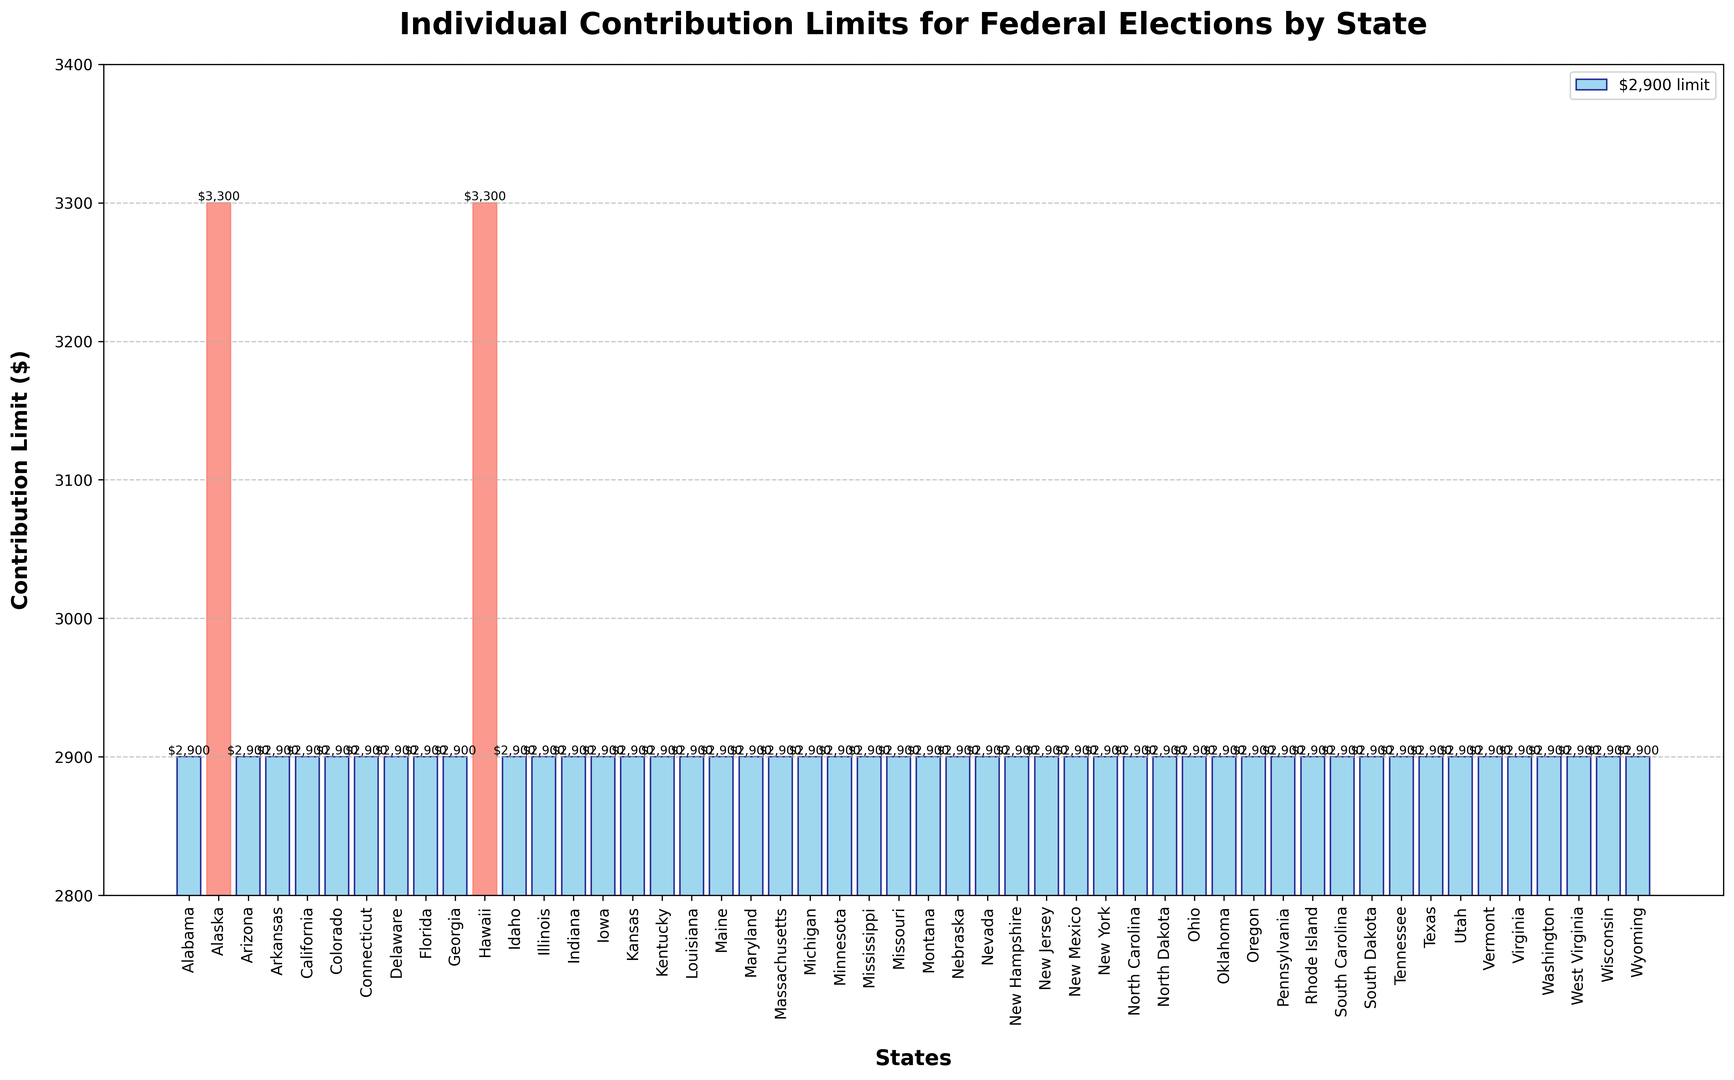What's the individual contribution limit for Alaska? Look at the bar corresponding to Alaska and check the height and label on the bar which reads $3,300.
Answer: $3,300 Which states have a higher individual contribution limit than the standard $2,900? The states with higher limits are highlighted in a different color (salmon). From the figure, these states are Alaska and Hawaii.
Answer: Alaska, Hawaii How many states have the standard individual contribution limit of $2,900? Count the number of bars that are not highlighted (all other bars except Alaska and Hawaii), which amounts to 49 out of 51 states listed.
Answer: 49 What is the contribution limit difference between the state with the highest limit and the states with the standard limit? The highest contribution limit is $3,300 (found in Alaska and Hawaii), and the standard limit is $2,900. The difference is $3,300 - $2,900 = $400.
Answer: $400 Which state symbol (bar) is the tallest, and what does it represent? The tallest bar corresponds to the state(s) with the highest contribution limit. Here, both Alaska and Hawaii have the tallest bars representing a $3,300 limit.
Answer: Alaska, Hawaii Do New York and California have the same individual contribution limit? Check the bars for both New York and California and see that they both reach $2,900, meaning they share the same limit.
Answer: Yes Identify the median contribution limit from the figure. The majority of states (49 out of 51) have the same contribution limit of $2,900. Therefore, the median is the common value, $2,900.
Answer: $2,900 What percentage of states have a contribution limit of more than $2,900? Out of 51 states, 2 have a limit of more than $2,900. The percentage is (2/51) * 100 ≈ 3.92%.
Answer: Approximately 3.92% Is there any state with a contribution limit below $2,900? Reviewing the figure, all states have either a $2,900 or $3,300 limit, so there are no states with a limit below $2,900.
Answer: No 